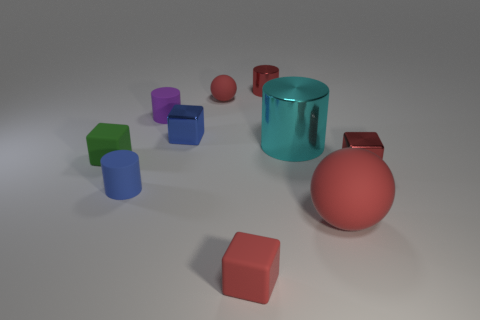What size is the red shiny thing in front of the matte block left of the small red matte thing behind the tiny purple matte cylinder?
Offer a terse response. Small. There is a blue block that is the same size as the blue cylinder; what is it made of?
Keep it short and to the point. Metal. Are there any red blocks that have the same size as the blue rubber cylinder?
Keep it short and to the point. Yes. There is a cylinder behind the purple thing; is its size the same as the small red matte ball?
Provide a short and direct response. Yes. What is the shape of the red object that is both right of the small red matte cube and behind the small purple thing?
Provide a succinct answer. Cylinder. Are there more shiny cylinders in front of the tiny red rubber ball than red metal cylinders?
Ensure brevity in your answer.  No. The other block that is made of the same material as the blue block is what size?
Offer a terse response. Small. What number of balls have the same color as the tiny metallic cylinder?
Your answer should be very brief. 2. Do the matte sphere that is behind the small blue cylinder and the big matte sphere have the same color?
Offer a very short reply. Yes. Are there an equal number of small red shiny cylinders to the right of the large red matte thing and shiny objects that are left of the big cylinder?
Give a very brief answer. No. 